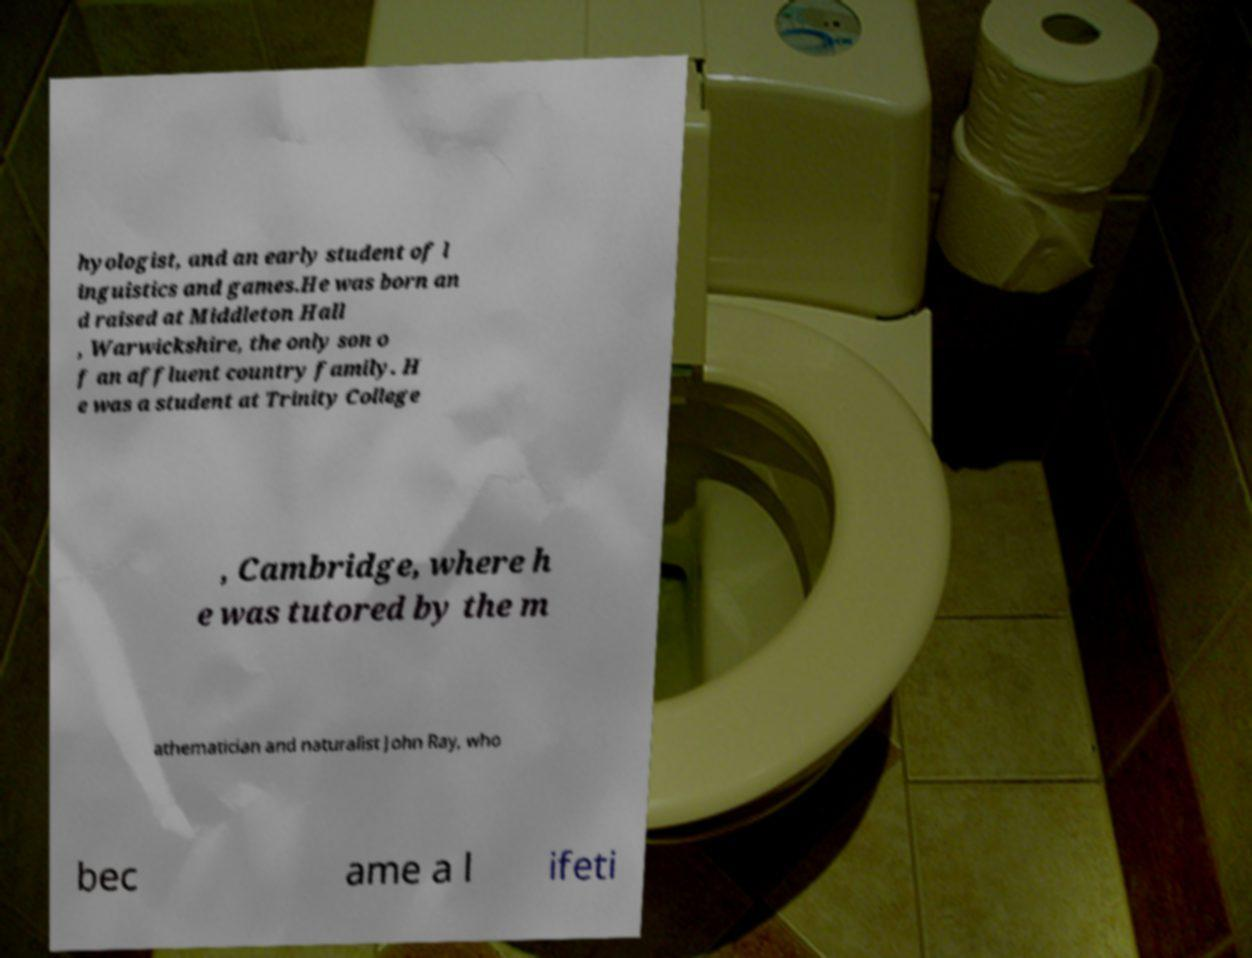Can you accurately transcribe the text from the provided image for me? hyologist, and an early student of l inguistics and games.He was born an d raised at Middleton Hall , Warwickshire, the only son o f an affluent country family. H e was a student at Trinity College , Cambridge, where h e was tutored by the m athematician and naturalist John Ray, who bec ame a l ifeti 